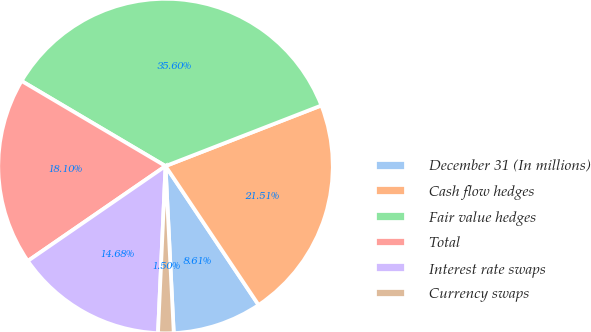<chart> <loc_0><loc_0><loc_500><loc_500><pie_chart><fcel>December 31 (In millions)<fcel>Cash flow hedges<fcel>Fair value hedges<fcel>Total<fcel>Interest rate swaps<fcel>Currency swaps<nl><fcel>8.61%<fcel>21.51%<fcel>35.6%<fcel>18.1%<fcel>14.68%<fcel>1.5%<nl></chart> 